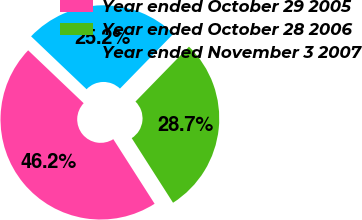Convert chart. <chart><loc_0><loc_0><loc_500><loc_500><pie_chart><fcel>Year ended October 29 2005<fcel>Year ended October 28 2006<fcel>Year ended November 3 2007<nl><fcel>46.17%<fcel>28.65%<fcel>25.18%<nl></chart> 